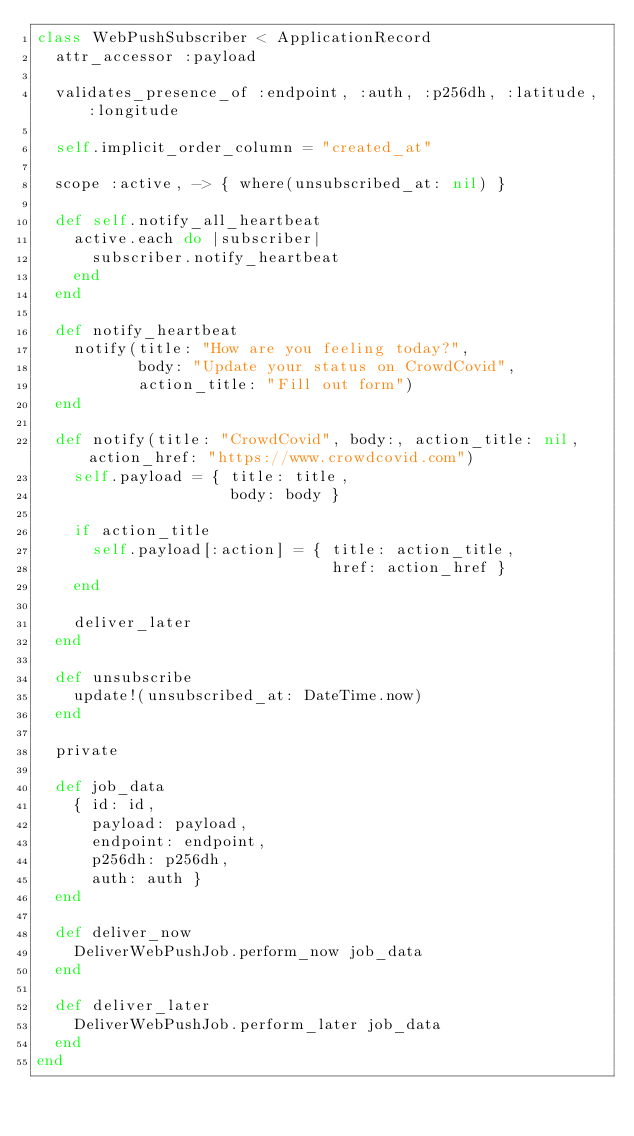<code> <loc_0><loc_0><loc_500><loc_500><_Ruby_>class WebPushSubscriber < ApplicationRecord
  attr_accessor :payload

  validates_presence_of :endpoint, :auth, :p256dh, :latitude, :longitude

  self.implicit_order_column = "created_at"

  scope :active, -> { where(unsubscribed_at: nil) }

  def self.notify_all_heartbeat
    active.each do |subscriber|
      subscriber.notify_heartbeat
    end
  end

  def notify_heartbeat
    notify(title: "How are you feeling today?",
           body: "Update your status on CrowdCovid",
           action_title: "Fill out form")
  end

  def notify(title: "CrowdCovid", body:, action_title: nil, action_href: "https://www.crowdcovid.com")
    self.payload = { title: title,
                     body: body }

    if action_title
      self.payload[:action] = { title: action_title,
                                href: action_href }
    end

    deliver_later
  end

  def unsubscribe
    update!(unsubscribed_at: DateTime.now)
  end

  private

  def job_data
    { id: id,
      payload: payload,
      endpoint: endpoint,
      p256dh: p256dh,
      auth: auth }
  end

  def deliver_now
    DeliverWebPushJob.perform_now job_data
  end

  def deliver_later
    DeliverWebPushJob.perform_later job_data
  end
end
</code> 